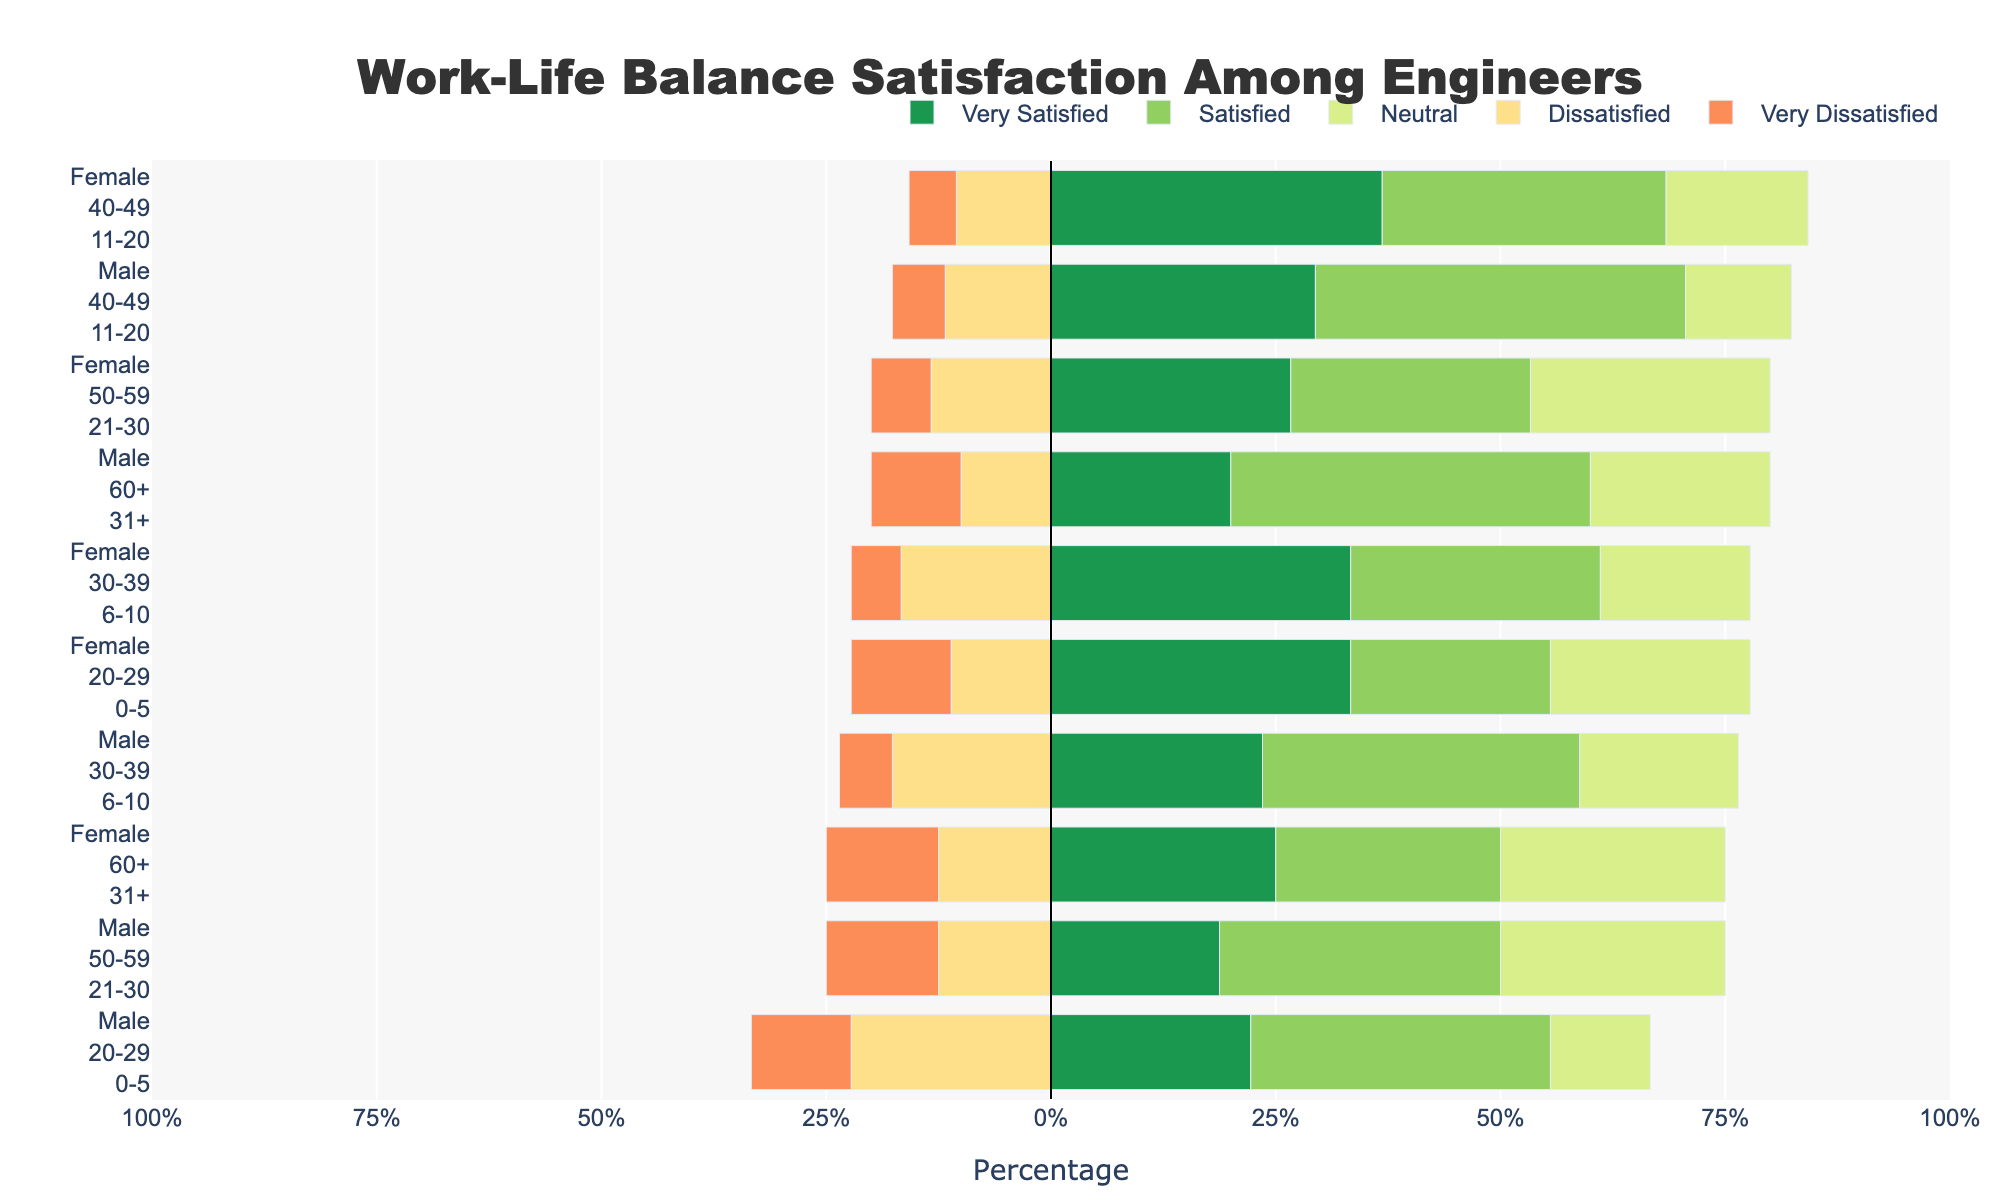What gender and age group have the highest percentage of "Very Satisfied" engineers? Looking at the "Very Satisfied" category, the highest percentage bar is for Female engineers in the 40-49 age group.
Answer: Female 40-49 Which experience group has a higher percentage of "Dissatisfied" engineers, Male 21-30 years or Female 21-30 years? By comparing the "Dissatisfied" category for both groups, Male 21-30 years have a 10% "Dissatisfied" rate, while Female 21-30 years also have a 10% "Dissatisfied" rate.
Answer: Equal For engineers with 0-5 years of experience, which gender has a higher overall satisfaction (sum of "Very Satisfied" and "Satisfied")? Sum the percentages of "Very Satisfied" and "Satisfied" for 0-5 years of experience. Males: 10+15=25%, Females: 15+10=25%. Both are equal.
Answer: Equal Among Male engineers, which age group has the highest percentage of "Neutral" satisfaction? The "Neutral" satisfaction bar shows the highest percentage for Male engineers is in the 50-59 age group with 20%.
Answer: Male 50-59 Which group has the lowest percentage of "Very Dissatisfied" engineers? The bars for "Very Dissatisfied" show the lowest percentage across all groups. Multiple groups (Male 60+ and Female 60+, Female 20-29) have the lowest value at 5%.
Answer: Male 60+, Female 60+, Female 20-29 Compare the total "Satisfied" and "Neutral" percentage for Female engineers in the 30-39 age group. Sum the percentages for "Satisfied" and "Neutral" for this group: 30+15=45% "Satisfied", 25+15=40% "Neutral". "Satisfied" is higher.
Answer: Satisfied Which group of engineers has fewer dissatisfied members, Male 40-49 years or Female 40-49 years? The "Dissatisfied" bar for Male 40-49 years is 10%, while for Female 40-49 years it is also 10%. Both are equal.
Answer: Equal For Female engineers, which age group with 31+ years of experience shows the highest levels of satisfaction (sum of "Very Satisfied" and "Satisfied")? Sum the "Very Satisfied" and "Satisfied" percentages for 31+ years of experience. There is only one group Female 60+, summing 10+10=20%.
Answer: Female 60+ 